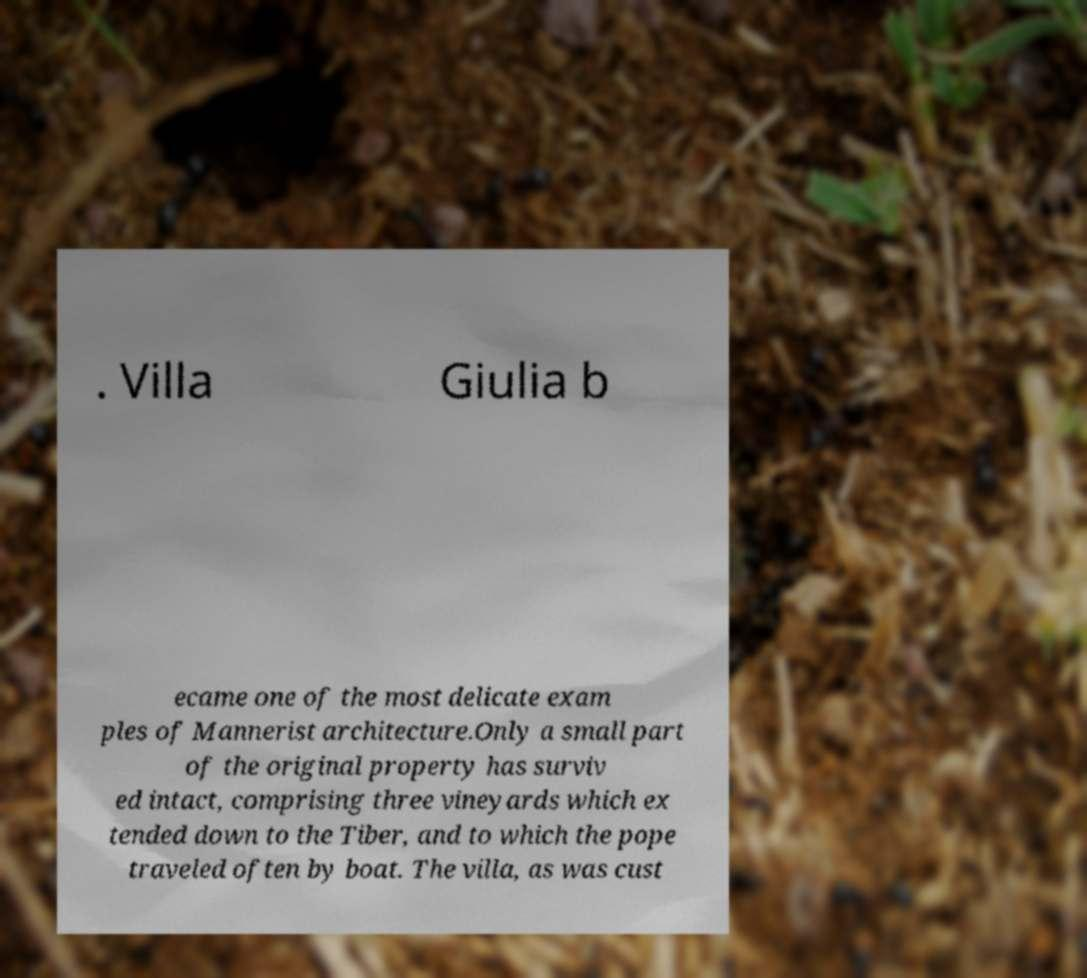I need the written content from this picture converted into text. Can you do that? . Villa Giulia b ecame one of the most delicate exam ples of Mannerist architecture.Only a small part of the original property has surviv ed intact, comprising three vineyards which ex tended down to the Tiber, and to which the pope traveled often by boat. The villa, as was cust 